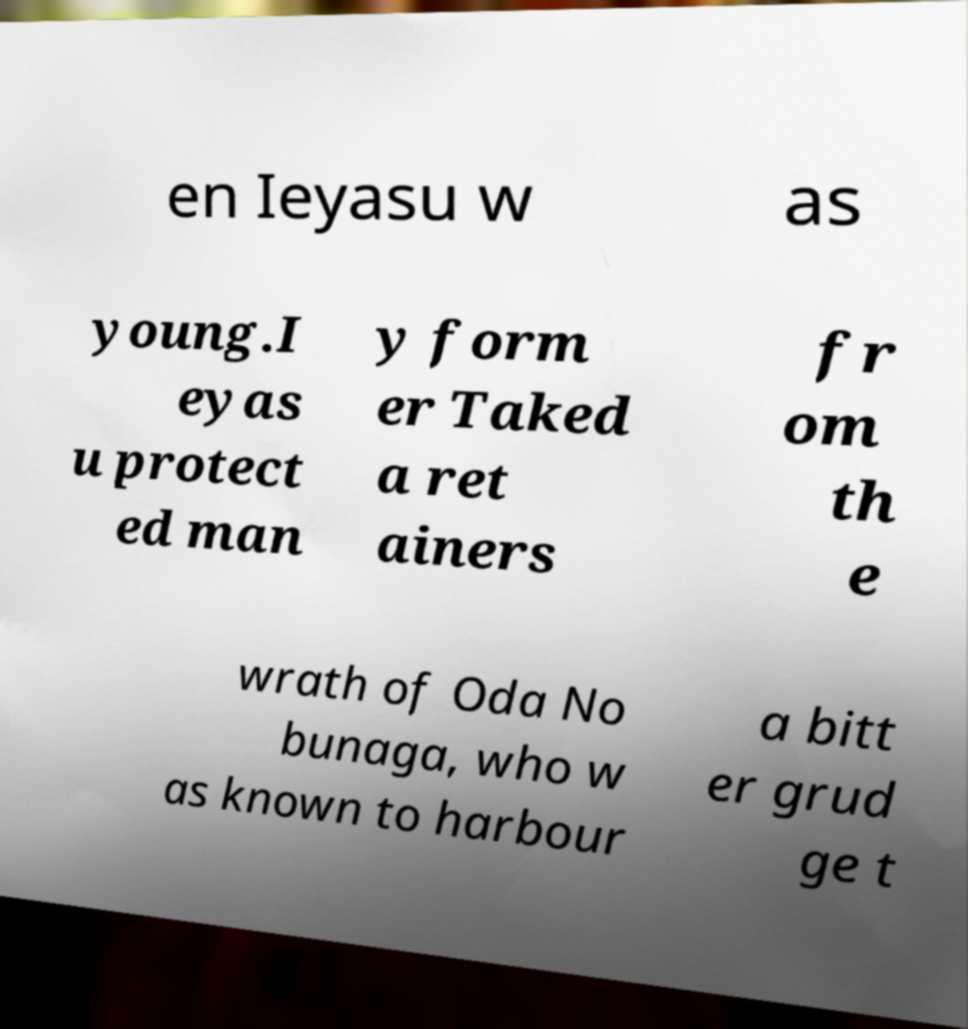There's text embedded in this image that I need extracted. Can you transcribe it verbatim? en Ieyasu w as young.I eyas u protect ed man y form er Taked a ret ainers fr om th e wrath of Oda No bunaga, who w as known to harbour a bitt er grud ge t 